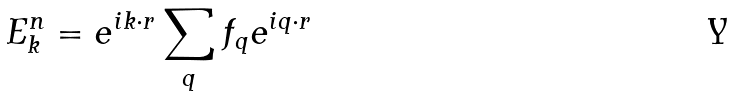<formula> <loc_0><loc_0><loc_500><loc_500>E _ { k } ^ { n } = e ^ { i k \cdot r } \sum _ { q } f _ { q } e ^ { i q \cdot r }</formula> 